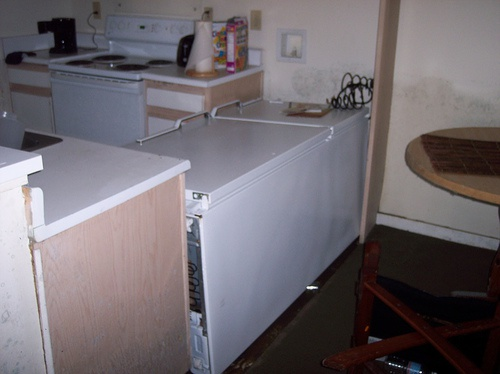Describe the objects in this image and their specific colors. I can see refrigerator in black, gray, and darkgray tones, oven in black and gray tones, and dining table in black, maroon, and gray tones in this image. 